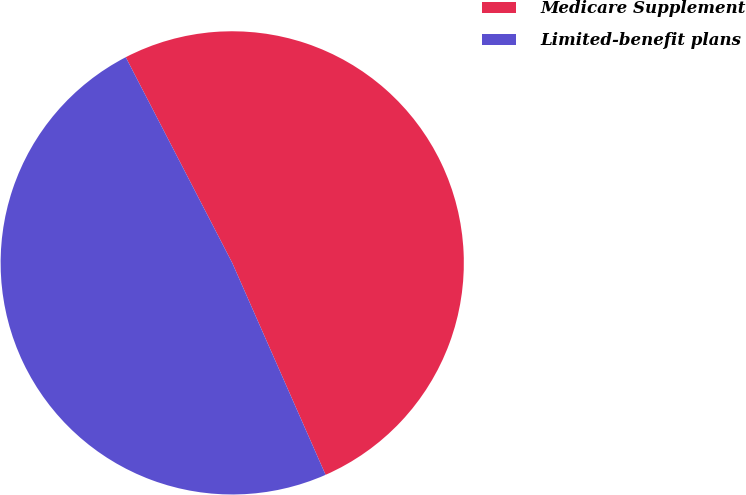Convert chart. <chart><loc_0><loc_0><loc_500><loc_500><pie_chart><fcel>Medicare Supplement<fcel>Limited-benefit plans<nl><fcel>51.0%<fcel>49.0%<nl></chart> 